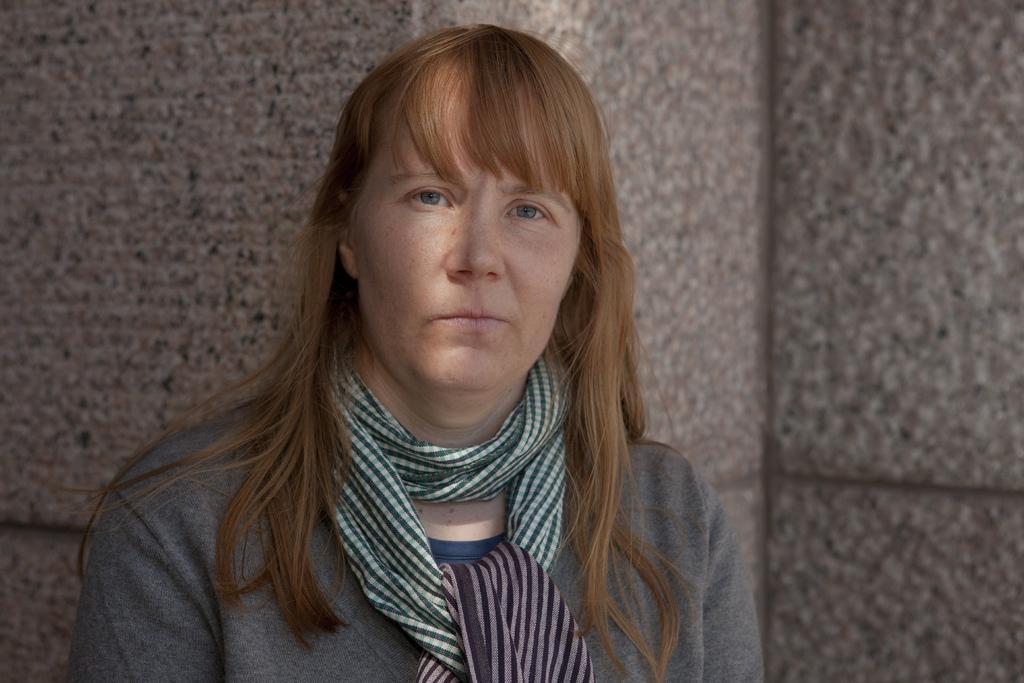Can you describe this image briefly? In the picture there is a woman, she is wearing a scarf. Behind the woman it is well. 